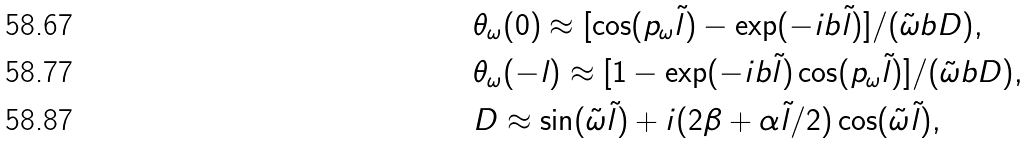<formula> <loc_0><loc_0><loc_500><loc_500>& \theta _ { \omega } ( 0 ) \approx [ \cos ( p _ { \omega } \tilde { l } ) - \exp ( - i b \tilde { l } ) ] / ( \tilde { \omega } b D ) , \\ & \theta _ { \omega } ( - l ) \approx [ 1 - \exp ( - i b \tilde { l } ) \cos ( p _ { \omega } \tilde { l } ) ] / ( \tilde { \omega } b D ) , \\ & D \approx \sin ( \tilde { \omega } \tilde { l } ) + i ( 2 \beta + \alpha \tilde { l } / 2 ) \cos ( \tilde { \omega } \tilde { l } ) ,</formula> 